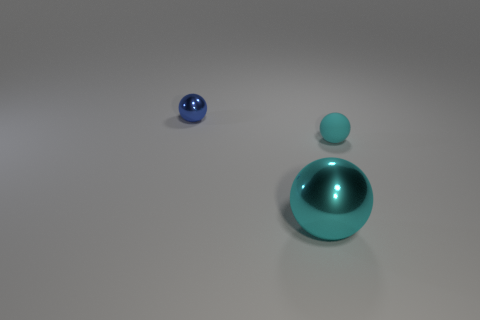Add 3 cyan spheres. How many objects exist? 6 Subtract 1 blue spheres. How many objects are left? 2 Subtract all large green matte cylinders. Subtract all large metal spheres. How many objects are left? 2 Add 1 tiny shiny objects. How many tiny shiny objects are left? 2 Add 3 cyan balls. How many cyan balls exist? 5 